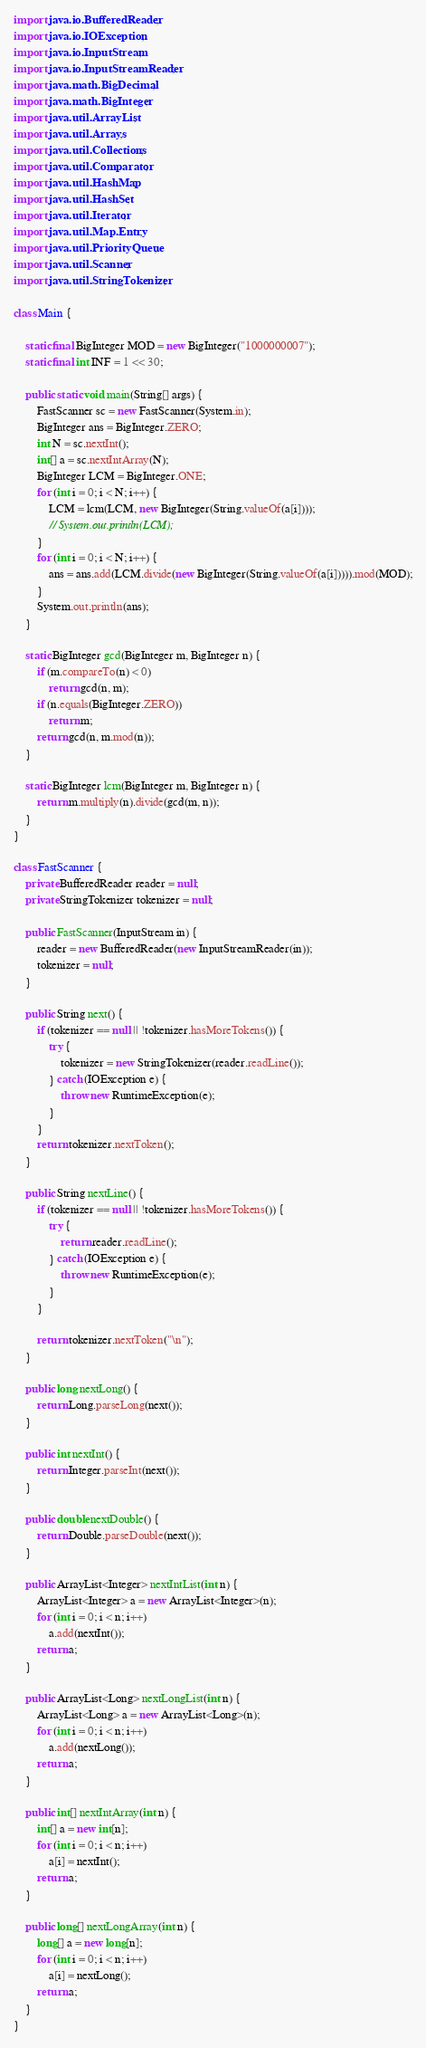Convert code to text. <code><loc_0><loc_0><loc_500><loc_500><_Java_>import java.io.BufferedReader;
import java.io.IOException;
import java.io.InputStream;
import java.io.InputStreamReader;
import java.math.BigDecimal;
import java.math.BigInteger;
import java.util.ArrayList;
import java.util.Arrays;
import java.util.Collections;
import java.util.Comparator;
import java.util.HashMap;
import java.util.HashSet;
import java.util.Iterator;
import java.util.Map.Entry;
import java.util.PriorityQueue;
import java.util.Scanner;
import java.util.StringTokenizer;

class Main {

    static final BigInteger MOD = new BigInteger("1000000007");
    static final int INF = 1 << 30;

    public static void main(String[] args) {
        FastScanner sc = new FastScanner(System.in);
        BigInteger ans = BigInteger.ZERO;
        int N = sc.nextInt();
        int[] a = sc.nextIntArray(N);
        BigInteger LCM = BigInteger.ONE;
        for (int i = 0; i < N; i++) {
            LCM = lcm(LCM, new BigInteger(String.valueOf(a[i])));
            // System.out.println(LCM);
        }
        for (int i = 0; i < N; i++) {
            ans = ans.add(LCM.divide(new BigInteger(String.valueOf(a[i])))).mod(MOD);
        }
        System.out.println(ans);
    }

    static BigInteger gcd(BigInteger m, BigInteger n) {
        if (m.compareTo(n) < 0)
            return gcd(n, m);
        if (n.equals(BigInteger.ZERO))
            return m;
        return gcd(n, m.mod(n));
    }

    static BigInteger lcm(BigInteger m, BigInteger n) {
        return m.multiply(n).divide(gcd(m, n));
    }
}

class FastScanner {
    private BufferedReader reader = null;
    private StringTokenizer tokenizer = null;

    public FastScanner(InputStream in) {
        reader = new BufferedReader(new InputStreamReader(in));
        tokenizer = null;
    }

    public String next() {
        if (tokenizer == null || !tokenizer.hasMoreTokens()) {
            try {
                tokenizer = new StringTokenizer(reader.readLine());
            } catch (IOException e) {
                throw new RuntimeException(e);
            }
        }
        return tokenizer.nextToken();
    }

    public String nextLine() {
        if (tokenizer == null || !tokenizer.hasMoreTokens()) {
            try {
                return reader.readLine();
            } catch (IOException e) {
                throw new RuntimeException(e);
            }
        }

        return tokenizer.nextToken("\n");
    }

    public long nextLong() {
        return Long.parseLong(next());
    }

    public int nextInt() {
        return Integer.parseInt(next());
    }

    public double nextDouble() {
        return Double.parseDouble(next());
    }

    public ArrayList<Integer> nextIntList(int n) {
        ArrayList<Integer> a = new ArrayList<Integer>(n);
        for (int i = 0; i < n; i++)
            a.add(nextInt());
        return a;
    }

    public ArrayList<Long> nextLongList(int n) {
        ArrayList<Long> a = new ArrayList<Long>(n);
        for (int i = 0; i < n; i++)
            a.add(nextLong());
        return a;
    }

    public int[] nextIntArray(int n) {
        int[] a = new int[n];
        for (int i = 0; i < n; i++)
            a[i] = nextInt();
        return a;
    }

    public long[] nextLongArray(int n) {
        long[] a = new long[n];
        for (int i = 0; i < n; i++)
            a[i] = nextLong();
        return a;
    }
}</code> 